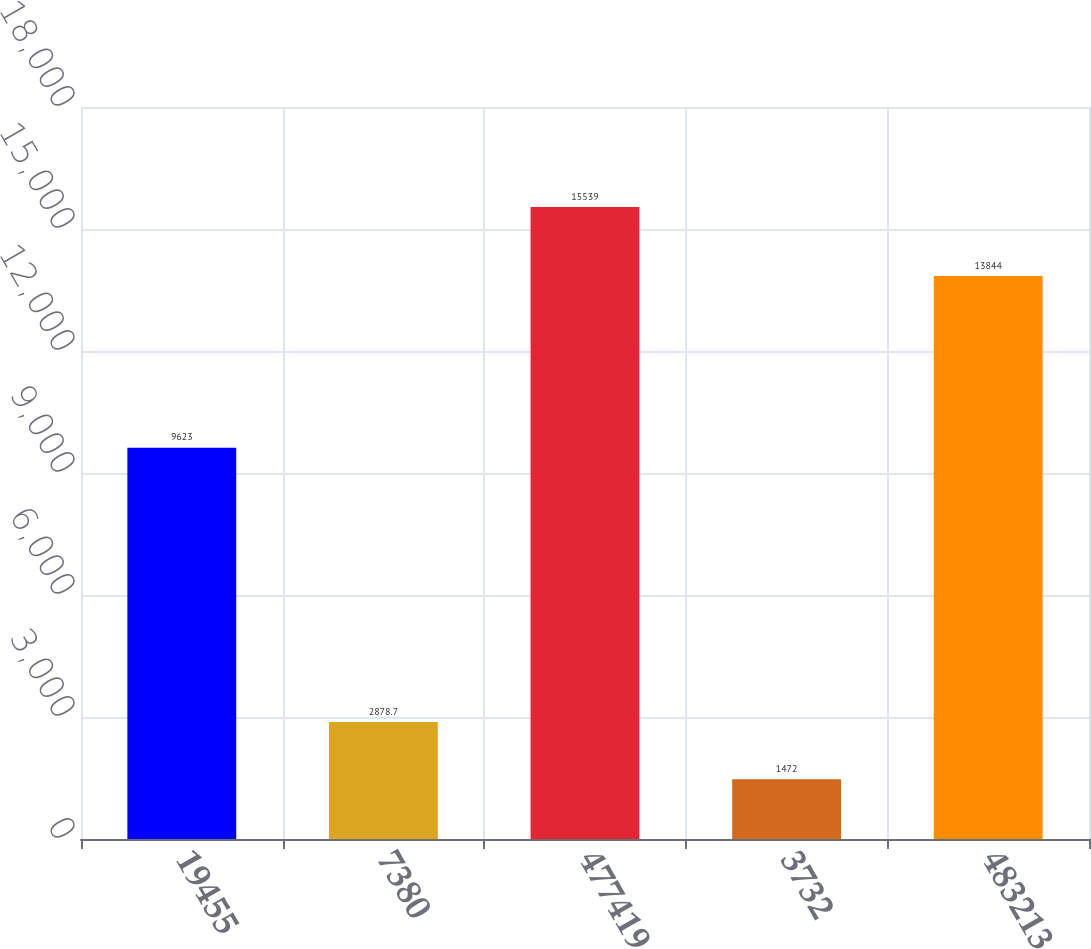<chart> <loc_0><loc_0><loc_500><loc_500><bar_chart><fcel>19455<fcel>7380<fcel>477419<fcel>3732<fcel>483213<nl><fcel>9623<fcel>2878.7<fcel>15539<fcel>1472<fcel>13844<nl></chart> 